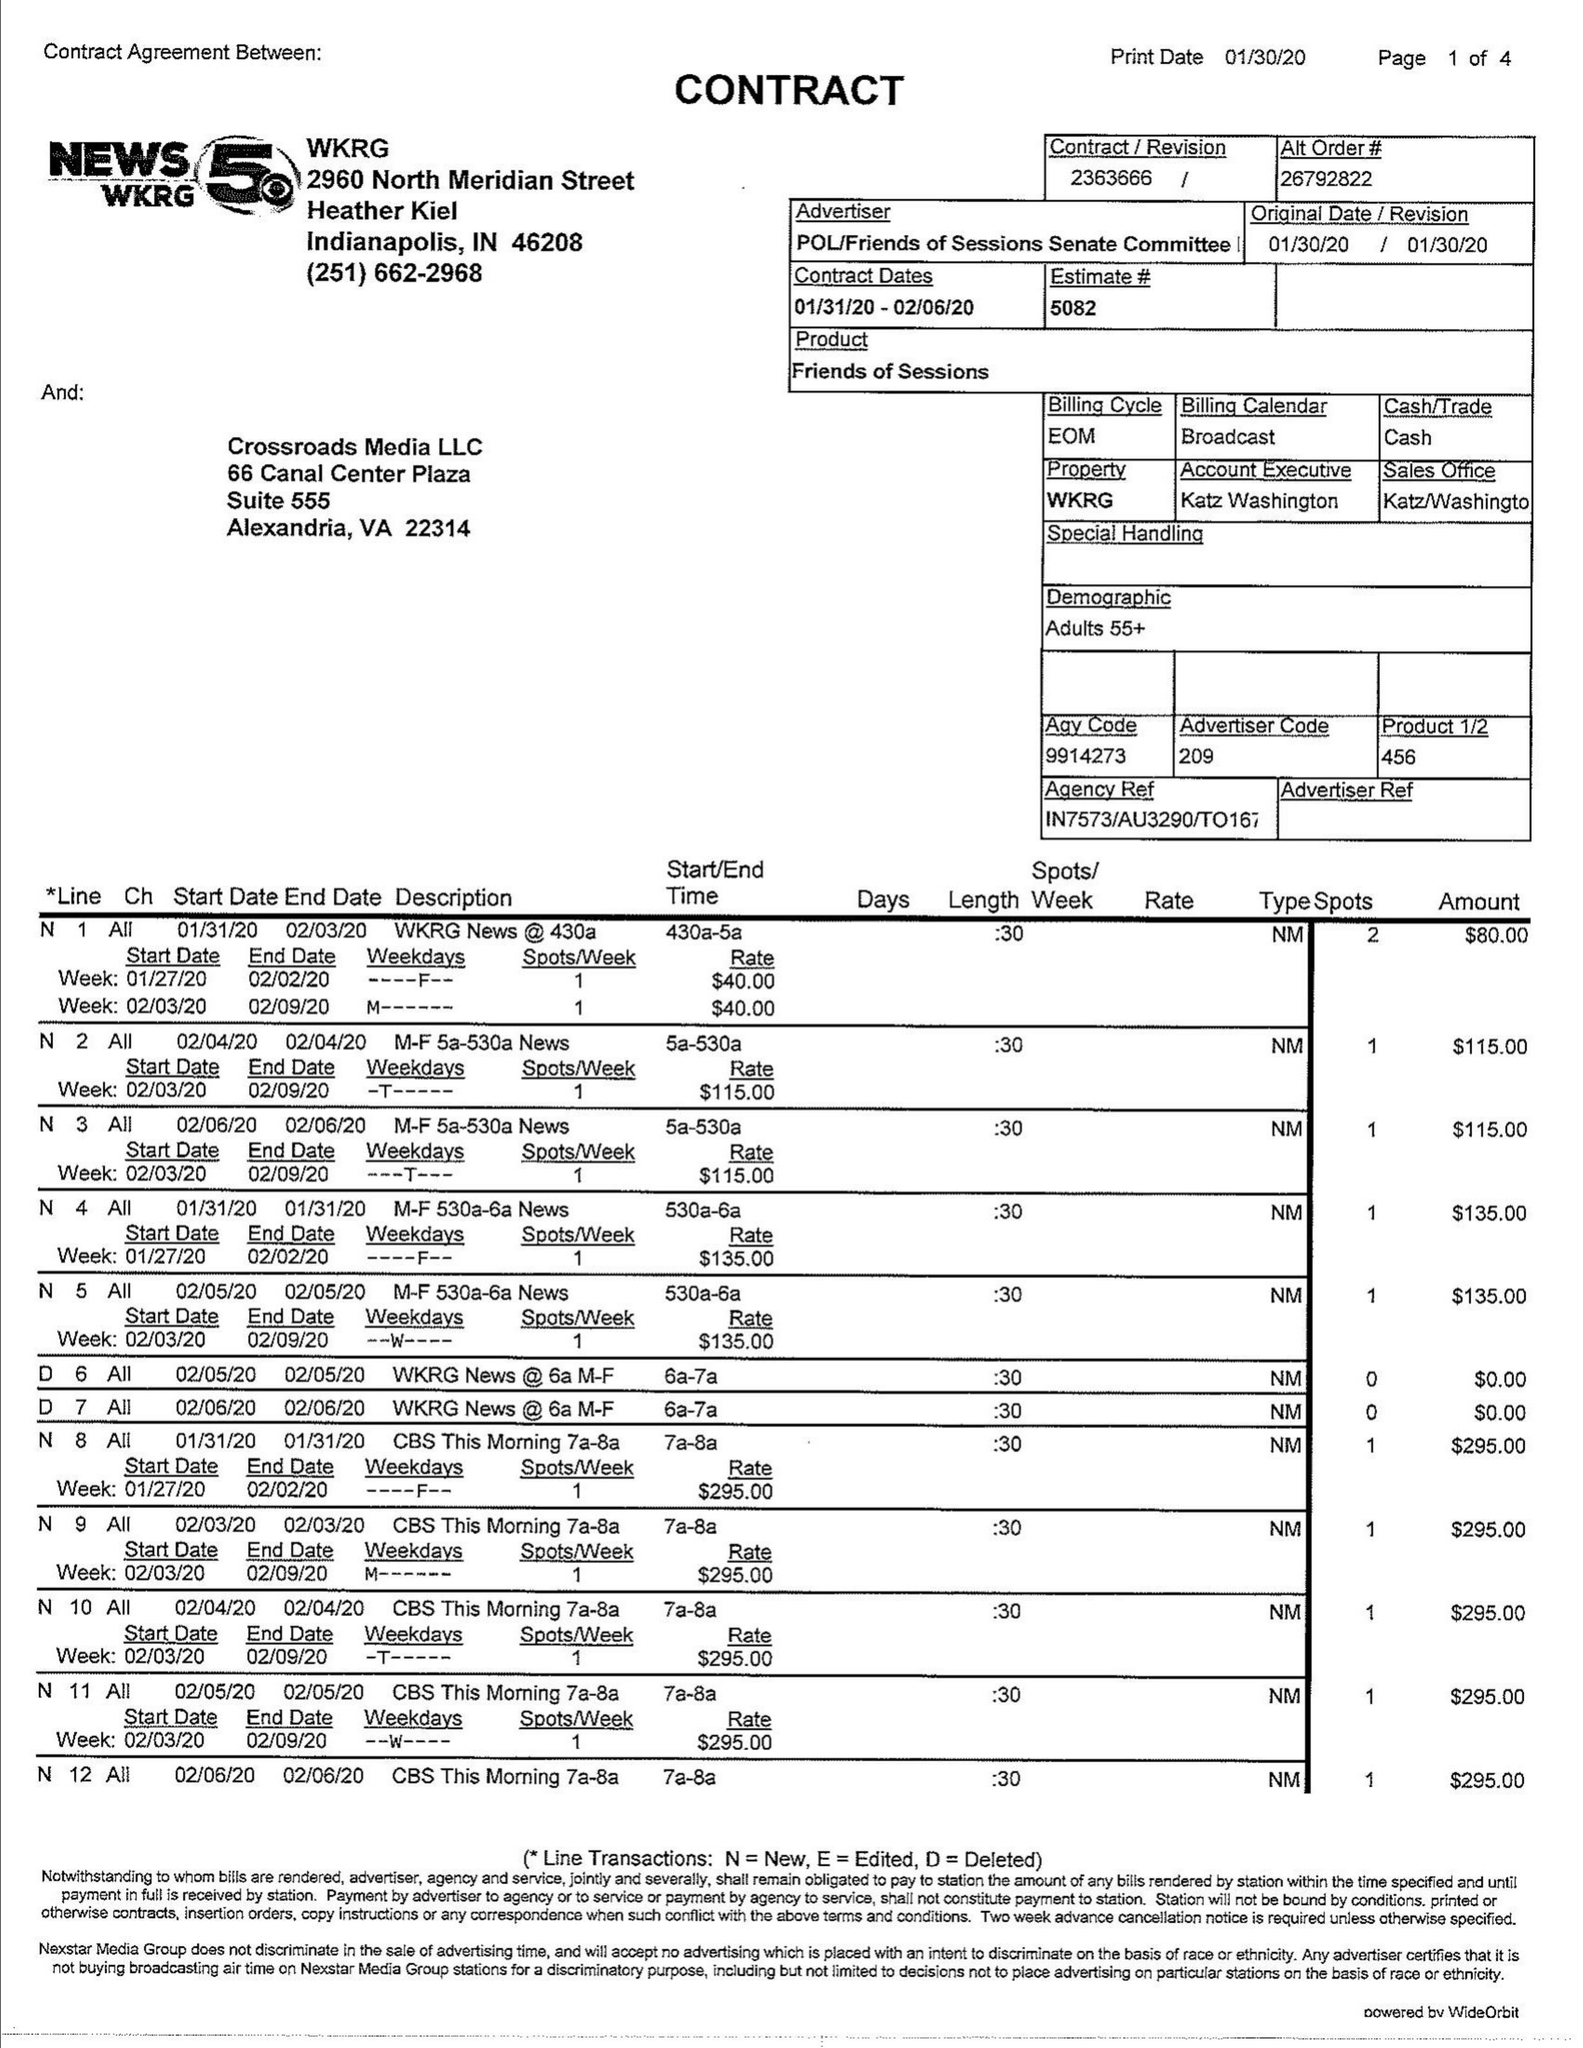What is the value for the advertiser?
Answer the question using a single word or phrase. POL/FRIENDSOFSESSIONSSENATECOMMITTEE 